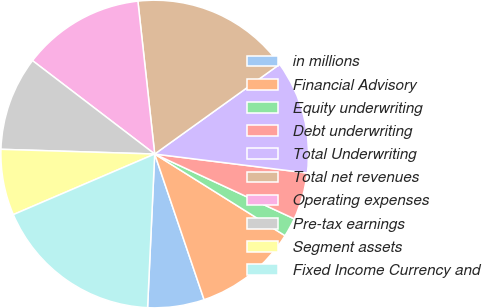Convert chart. <chart><loc_0><loc_0><loc_500><loc_500><pie_chart><fcel>in millions<fcel>Financial Advisory<fcel>Equity underwriting<fcel>Debt underwriting<fcel>Total Underwriting<fcel>Total net revenues<fcel>Operating expenses<fcel>Pre-tax earnings<fcel>Segment assets<fcel>Fixed Income Currency and<nl><fcel>5.94%<fcel>10.89%<fcel>1.99%<fcel>4.95%<fcel>11.88%<fcel>16.83%<fcel>12.87%<fcel>9.9%<fcel>6.93%<fcel>17.82%<nl></chart> 